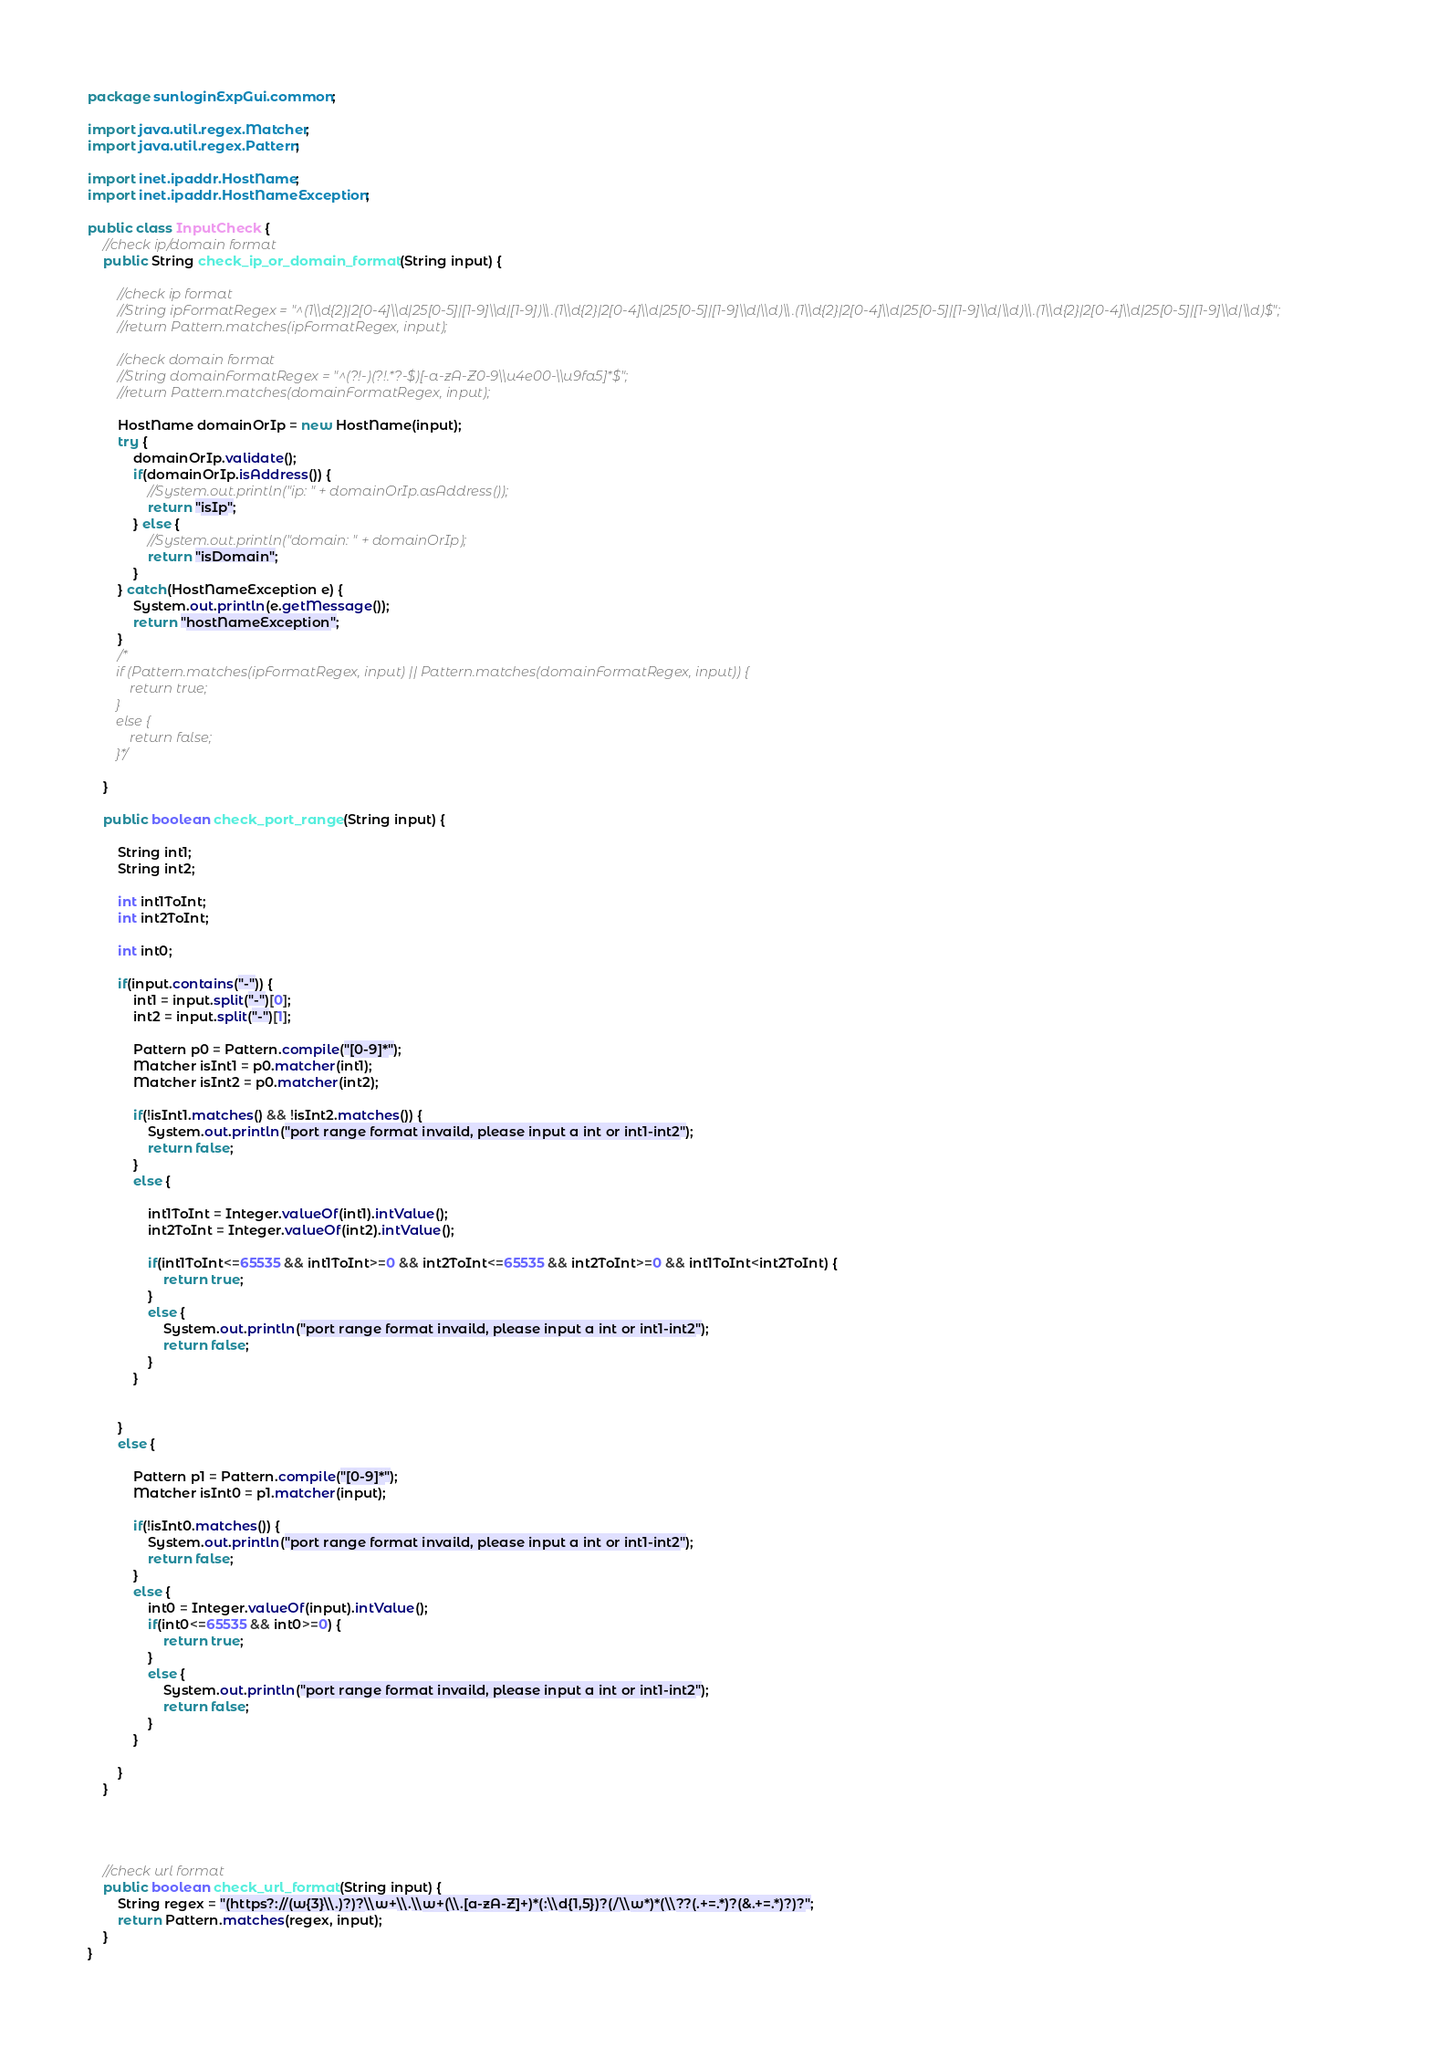Convert code to text. <code><loc_0><loc_0><loc_500><loc_500><_Java_>package sunloginExpGui.common;

import java.util.regex.Matcher;
import java.util.regex.Pattern;

import inet.ipaddr.HostName;
import inet.ipaddr.HostNameException;

public class InputCheck {
	//check ip/domain format
	public String check_ip_or_domain_format(String input) {
		
		//check ip format
		//String ipFormatRegex = "^(1\\d{2}|2[0-4]\\d|25[0-5]|[1-9]\\d|[1-9])\\.(1\\d{2}|2[0-4]\\d|25[0-5]|[1-9]\\d|\\d)\\.(1\\d{2}|2[0-4]\\d|25[0-5]|[1-9]\\d|\\d)\\.(1\\d{2}|2[0-4]\\d|25[0-5]|[1-9]\\d|\\d)$";
	    //return Pattern.matches(ipFormatRegex, input); 
	    
	    //check domain format
        //String domainFormatRegex = "^(?!-)(?!.*?-$)[-a-zA-Z0-9\\u4e00-\\u9fa5]*$";
        //return Pattern.matches(domainFormatRegex, input);
        
		HostName domainOrIp = new HostName(input);
		try {
			domainOrIp.validate();
			if(domainOrIp.isAddress()) {
				//System.out.println("ip: " + domainOrIp.asAddress());
				return "isIp";
			} else {
				//System.out.println("domain: " + domainOrIp);
				return "isDomain";
			}
		} catch(HostNameException e) {
			System.out.println(e.getMessage());
			return "hostNameException";
		}
		/*
        if (Pattern.matches(ipFormatRegex, input) || Pattern.matches(domainFormatRegex, input)) {
        	return true;
        }
        else {
        	return false;
        }*/
        
	}
	
	public boolean check_port_range(String input) {
		
		String int1;
		String int2;
		
		int int1ToInt;
		int int2ToInt;
		
		int int0;
		
		if(input.contains("-")) {
			int1 = input.split("-")[0];
			int2 = input.split("-")[1];
			
			Pattern p0 = Pattern.compile("[0-9]*");
			Matcher isInt1 = p0.matcher(int1);
			Matcher isInt2 = p0.matcher(int2);
			
			if(!isInt1.matches() && !isInt2.matches()) {
				System.out.println("port range format invaild, please input a int or int1-int2");
				return false;
			}
			else {
				
				int1ToInt = Integer.valueOf(int1).intValue();
				int2ToInt = Integer.valueOf(int2).intValue();
				
				if(int1ToInt<=65535 && int1ToInt>=0 && int2ToInt<=65535 && int2ToInt>=0 && int1ToInt<int2ToInt) {
					return true;
				}
				else {
					System.out.println("port range format invaild, please input a int or int1-int2");
					return false;
				}
			}
			
			
		}
		else {
			
			Pattern p1 = Pattern.compile("[0-9]*");
			Matcher isInt0 = p1.matcher(input);
			
			if(!isInt0.matches()) {
				System.out.println("port range format invaild, please input a int or int1-int2");
				return false;
			}
			else {
				int0 = Integer.valueOf(input).intValue();
				if(int0<=65535 && int0>=0) {
					return true;
				}
				else {
					System.out.println("port range format invaild, please input a int or int1-int2");
					return false;
				}
			}
		
		}
	}
	
	
	
	
	//check url format
	public boolean check_url_format(String input) {
		String regex = "(https?://(w{3}\\.)?)?\\w+\\.\\w+(\\.[a-zA-Z]+)*(:\\d{1,5})?(/\\w*)*(\\??(.+=.*)?(&.+=.*)?)?"; 
	    return Pattern.matches(regex, input); 
	}
}
</code> 